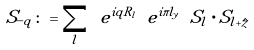Convert formula to latex. <formula><loc_0><loc_0><loc_500><loc_500>S _ { - { q } } \colon = \sum _ { l } \ e ^ { i { q } { R } _ { l } } \ e ^ { i \pi l _ { y } } \ { S } _ { l } \cdot { S } _ { { l } + \hat { z } }</formula> 